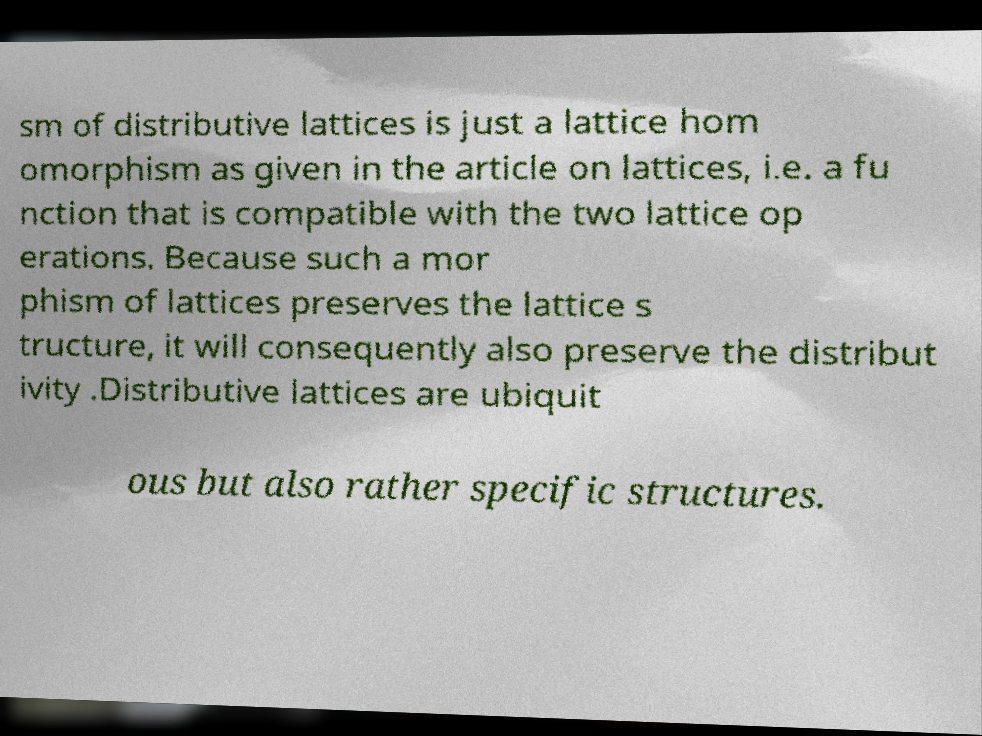Please read and relay the text visible in this image. What does it say? sm of distributive lattices is just a lattice hom omorphism as given in the article on lattices, i.e. a fu nction that is compatible with the two lattice op erations. Because such a mor phism of lattices preserves the lattice s tructure, it will consequently also preserve the distribut ivity .Distributive lattices are ubiquit ous but also rather specific structures. 